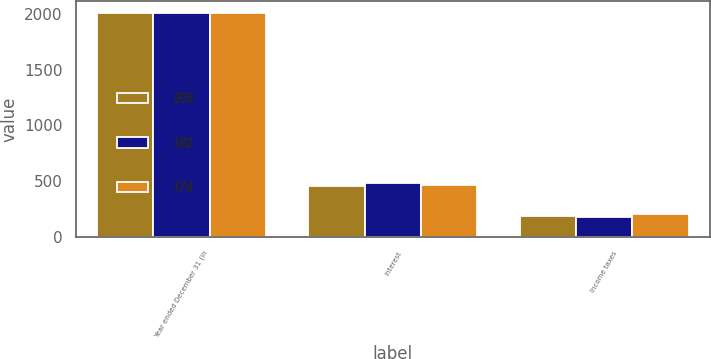<chart> <loc_0><loc_0><loc_500><loc_500><stacked_bar_chart><ecel><fcel>Year ended December 31 (in<fcel>Interest<fcel>Income taxes<nl><fcel>205<fcel>2015<fcel>456<fcel>182<nl><fcel>182<fcel>2014<fcel>485<fcel>174<nl><fcel>174<fcel>2013<fcel>462<fcel>205<nl></chart> 